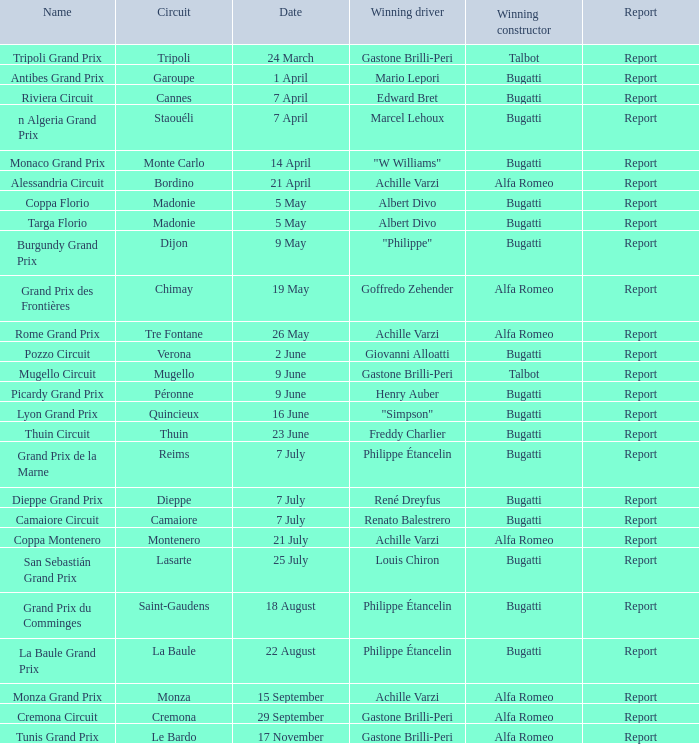Could you parse the entire table as a dict? {'header': ['Name', 'Circuit', 'Date', 'Winning driver', 'Winning constructor', 'Report'], 'rows': [['Tripoli Grand Prix', 'Tripoli', '24 March', 'Gastone Brilli-Peri', 'Talbot', 'Report'], ['Antibes Grand Prix', 'Garoupe', '1 April', 'Mario Lepori', 'Bugatti', 'Report'], ['Riviera Circuit', 'Cannes', '7 April', 'Edward Bret', 'Bugatti', 'Report'], ['n Algeria Grand Prix', 'Staouéli', '7 April', 'Marcel Lehoux', 'Bugatti', 'Report'], ['Monaco Grand Prix', 'Monte Carlo', '14 April', '"W Williams"', 'Bugatti', 'Report'], ['Alessandria Circuit', 'Bordino', '21 April', 'Achille Varzi', 'Alfa Romeo', 'Report'], ['Coppa Florio', 'Madonie', '5 May', 'Albert Divo', 'Bugatti', 'Report'], ['Targa Florio', 'Madonie', '5 May', 'Albert Divo', 'Bugatti', 'Report'], ['Burgundy Grand Prix', 'Dijon', '9 May', '"Philippe"', 'Bugatti', 'Report'], ['Grand Prix des Frontières', 'Chimay', '19 May', 'Goffredo Zehender', 'Alfa Romeo', 'Report'], ['Rome Grand Prix', 'Tre Fontane', '26 May', 'Achille Varzi', 'Alfa Romeo', 'Report'], ['Pozzo Circuit', 'Verona', '2 June', 'Giovanni Alloatti', 'Bugatti', 'Report'], ['Mugello Circuit', 'Mugello', '9 June', 'Gastone Brilli-Peri', 'Talbot', 'Report'], ['Picardy Grand Prix', 'Péronne', '9 June', 'Henry Auber', 'Bugatti', 'Report'], ['Lyon Grand Prix', 'Quincieux', '16 June', '"Simpson"', 'Bugatti', 'Report'], ['Thuin Circuit', 'Thuin', '23 June', 'Freddy Charlier', 'Bugatti', 'Report'], ['Grand Prix de la Marne', 'Reims', '7 July', 'Philippe Étancelin', 'Bugatti', 'Report'], ['Dieppe Grand Prix', 'Dieppe', '7 July', 'René Dreyfus', 'Bugatti', 'Report'], ['Camaiore Circuit', 'Camaiore', '7 July', 'Renato Balestrero', 'Bugatti', 'Report'], ['Coppa Montenero', 'Montenero', '21 July', 'Achille Varzi', 'Alfa Romeo', 'Report'], ['San Sebastián Grand Prix', 'Lasarte', '25 July', 'Louis Chiron', 'Bugatti', 'Report'], ['Grand Prix du Comminges', 'Saint-Gaudens', '18 August', 'Philippe Étancelin', 'Bugatti', 'Report'], ['La Baule Grand Prix', 'La Baule', '22 August', 'Philippe Étancelin', 'Bugatti', 'Report'], ['Monza Grand Prix', 'Monza', '15 September', 'Achille Varzi', 'Alfa Romeo', 'Report'], ['Cremona Circuit', 'Cremona', '29 September', 'Gastone Brilli-Peri', 'Alfa Romeo', 'Report'], ['Tunis Grand Prix', 'Le Bardo', '17 November', 'Gastone Brilli-Peri', 'Alfa Romeo', 'Report']]} What Winning driver has a Name of mugello circuit? Gastone Brilli-Peri. 